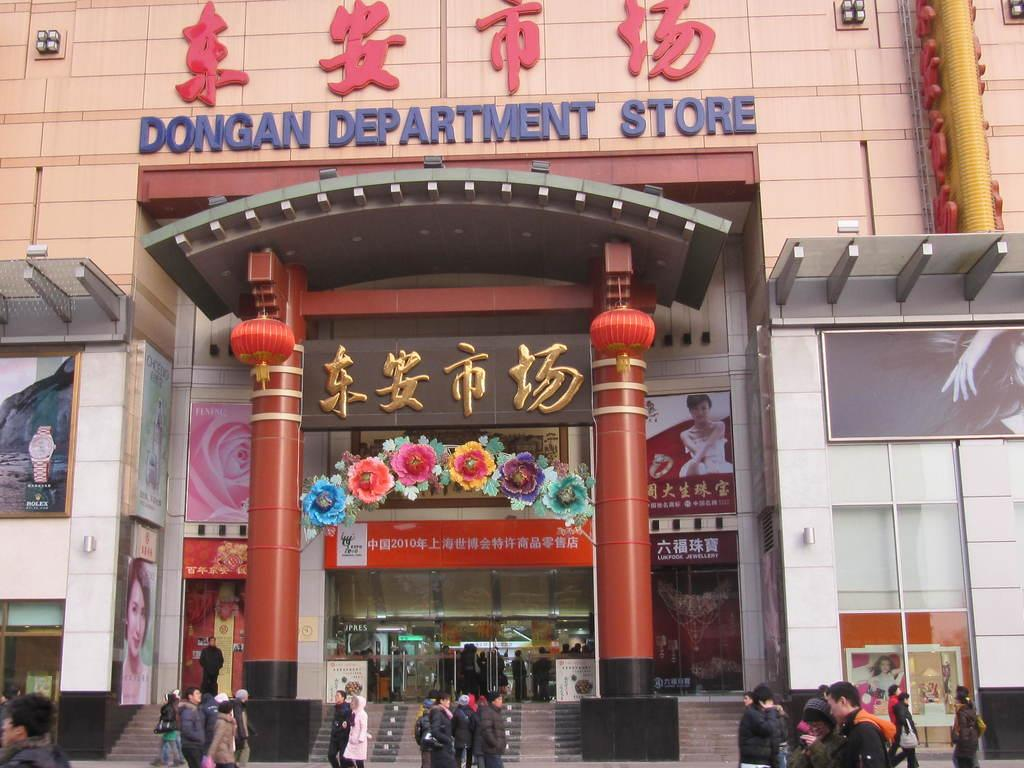What type of building is in the image? There is a big shopping mall in the image. Where is the shopping mall located in the image? The shopping mall is in the background. What are the people in the image doing? The people are walking on the road in front of the shopping mall. What shape is the shock in the image? There is no shock present in the image, and therefore no shape can be attributed to it. 